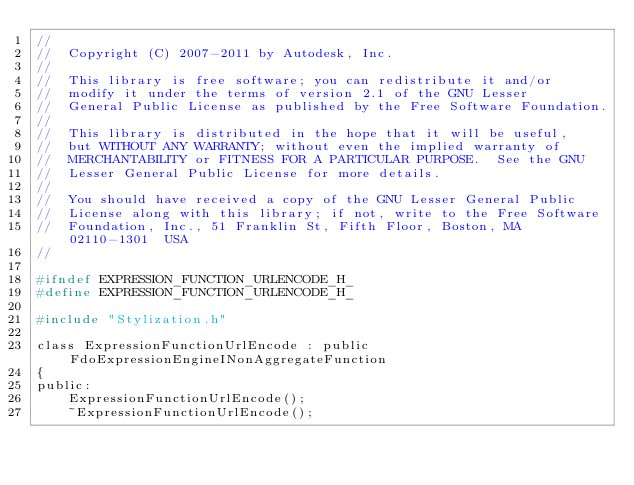Convert code to text. <code><loc_0><loc_0><loc_500><loc_500><_C_>//
//  Copyright (C) 2007-2011 by Autodesk, Inc.
//
//  This library is free software; you can redistribute it and/or
//  modify it under the terms of version 2.1 of the GNU Lesser
//  General Public License as published by the Free Software Foundation.
//
//  This library is distributed in the hope that it will be useful,
//  but WITHOUT ANY WARRANTY; without even the implied warranty of
//  MERCHANTABILITY or FITNESS FOR A PARTICULAR PURPOSE.  See the GNU
//  Lesser General Public License for more details.
//
//  You should have received a copy of the GNU Lesser General Public
//  License along with this library; if not, write to the Free Software
//  Foundation, Inc., 51 Franklin St, Fifth Floor, Boston, MA  02110-1301  USA
//

#ifndef EXPRESSION_FUNCTION_URLENCODE_H_
#define EXPRESSION_FUNCTION_URLENCODE_H_

#include "Stylization.h"

class ExpressionFunctionUrlEncode : public FdoExpressionEngineINonAggregateFunction
{
public:
    ExpressionFunctionUrlEncode();
    ~ExpressionFunctionUrlEncode();
</code> 